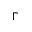<formula> <loc_0><loc_0><loc_500><loc_500>\Gamma</formula> 